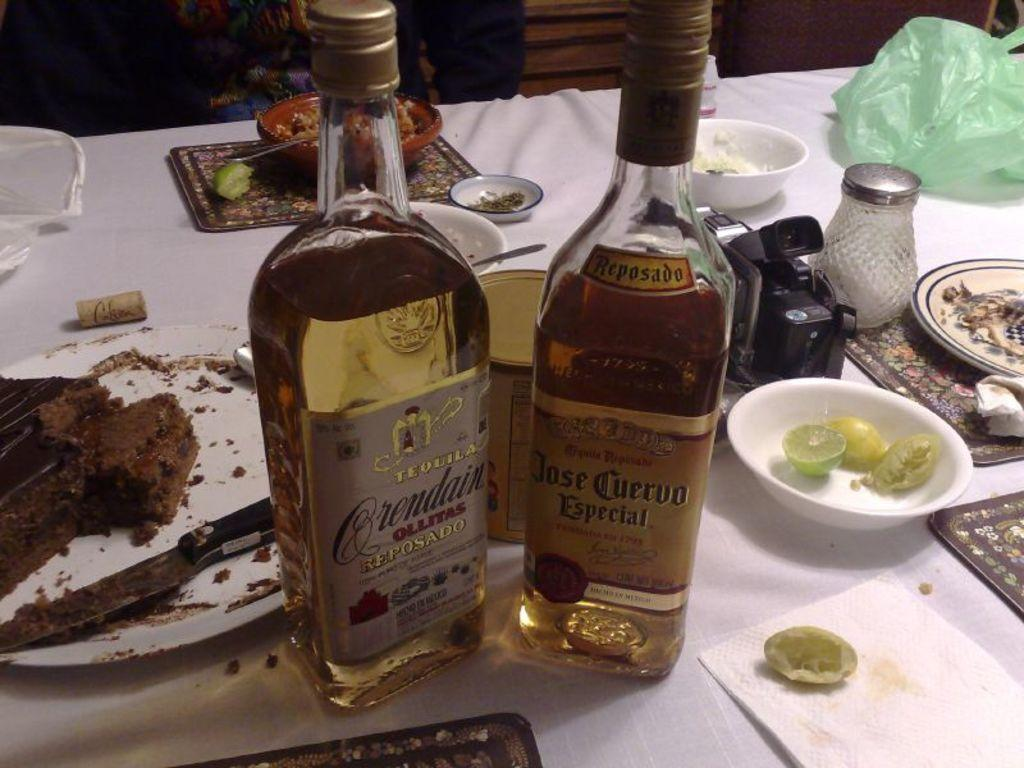<image>
Render a clear and concise summary of the photo. two bottles of liquor including Jose Cuervo on a table 